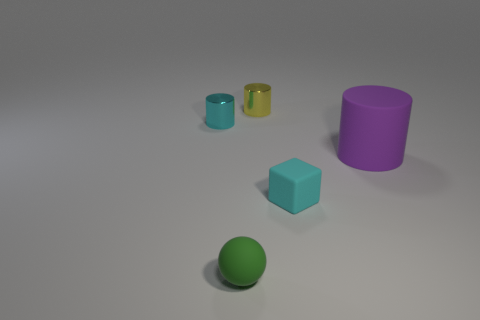What is the size of the cylinder that is the same color as the matte cube?
Make the answer very short. Small. What material is the tiny object in front of the cyan cube that is to the right of the tiny green matte ball?
Your answer should be very brief. Rubber. There is a small thing that is both behind the large rubber object and on the left side of the small yellow shiny object; what material is it made of?
Keep it short and to the point. Metal. Is the number of purple cylinders to the right of the tiny cyan cylinder the same as the number of yellow metal cylinders?
Make the answer very short. Yes. How many cyan objects are the same shape as the yellow shiny thing?
Your answer should be compact. 1. What size is the purple rubber object in front of the small cyan object that is behind the tiny rubber object that is behind the tiny green ball?
Keep it short and to the point. Large. Are the tiny cyan thing left of the small sphere and the yellow thing made of the same material?
Give a very brief answer. Yes. Are there an equal number of cyan cubes behind the small cyan metal cylinder and cyan objects behind the large rubber cylinder?
Offer a terse response. No. Are there any other things that have the same size as the purple matte cylinder?
Provide a short and direct response. No. There is a big purple thing that is the same shape as the tiny yellow object; what is it made of?
Your answer should be compact. Rubber. 